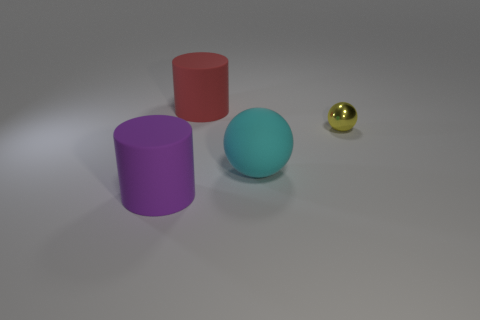Are there any tiny spheres left of the cyan sphere?
Your answer should be compact. No. Do the red rubber cylinder and the cylinder in front of the yellow ball have the same size?
Ensure brevity in your answer.  Yes. Are there any large rubber cylinders that have the same color as the matte sphere?
Your response must be concise. No. Are there any other tiny purple objects of the same shape as the tiny metal object?
Give a very brief answer. No. What is the shape of the thing that is left of the small yellow sphere and behind the big cyan rubber ball?
Make the answer very short. Cylinder. How many big cyan things are the same material as the yellow thing?
Give a very brief answer. 0. Are there fewer cyan rubber things in front of the yellow metal sphere than matte cylinders?
Give a very brief answer. Yes. Is there a metal sphere that is behind the rubber cylinder to the right of the large purple cylinder?
Offer a terse response. No. Is there anything else that has the same shape as the small yellow thing?
Your answer should be very brief. Yes. Do the purple matte cylinder and the shiny sphere have the same size?
Make the answer very short. No. 